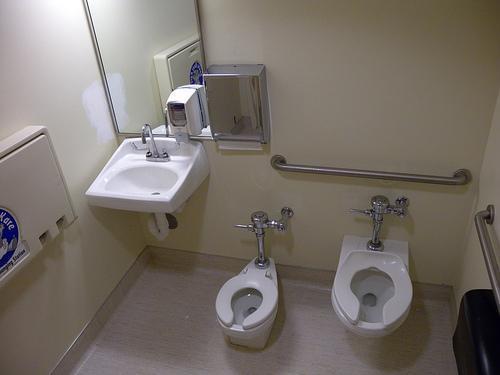How many toilets are there?
Give a very brief answer. 2. 